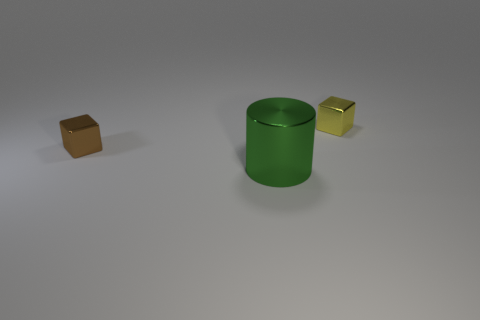Add 1 green cylinders. How many objects exist? 4 Subtract all cylinders. How many objects are left? 2 Subtract all big things. Subtract all yellow blocks. How many objects are left? 1 Add 3 large green metal objects. How many large green metal objects are left? 4 Add 1 large brown matte cylinders. How many large brown matte cylinders exist? 1 Subtract 1 green cylinders. How many objects are left? 2 